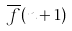Convert formula to latex. <formula><loc_0><loc_0><loc_500><loc_500>\overline { f } ( n + 1 )</formula> 